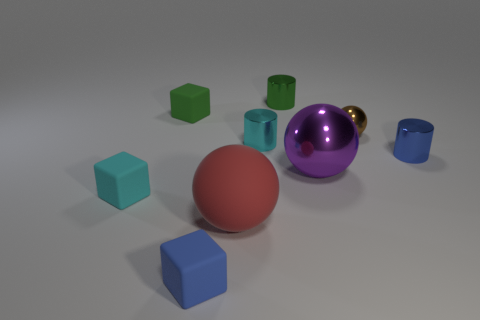What is the shape of the cyan object that is in front of the cyan cylinder that is in front of the small green matte object?
Keep it short and to the point. Cube. What material is the other purple object that is the same shape as the big matte thing?
Provide a short and direct response. Metal. The ball that is the same size as the green metal cylinder is what color?
Provide a succinct answer. Brown. Is the number of tiny matte cubes behind the matte sphere the same as the number of shiny things?
Make the answer very short. No. What color is the cylinder on the left side of the cylinder that is behind the brown shiny sphere?
Your answer should be compact. Cyan. There is a blue object to the right of the big ball that is on the left side of the large metal sphere; what is its size?
Offer a very short reply. Small. What number of other objects are there of the same size as the blue block?
Keep it short and to the point. 6. There is a tiny block behind the cyan thing on the right side of the tiny rubber object that is behind the purple thing; what color is it?
Make the answer very short. Green. How many other objects are there of the same shape as the cyan shiny object?
Your answer should be very brief. 2. There is a thing left of the tiny green rubber cube; what is its shape?
Make the answer very short. Cube. 